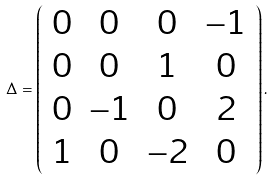<formula> <loc_0><loc_0><loc_500><loc_500>\Delta = \left ( \begin{array} { c c c c } { 0 } & { 0 } & { 0 } & { - 1 } \\ { 0 } & { 0 } & { 1 } & { 0 } \\ { 0 } & { - 1 } & { 0 } & { 2 } \\ { 1 } & { 0 } & { - 2 } & { 0 } \end{array} \right ) .</formula> 